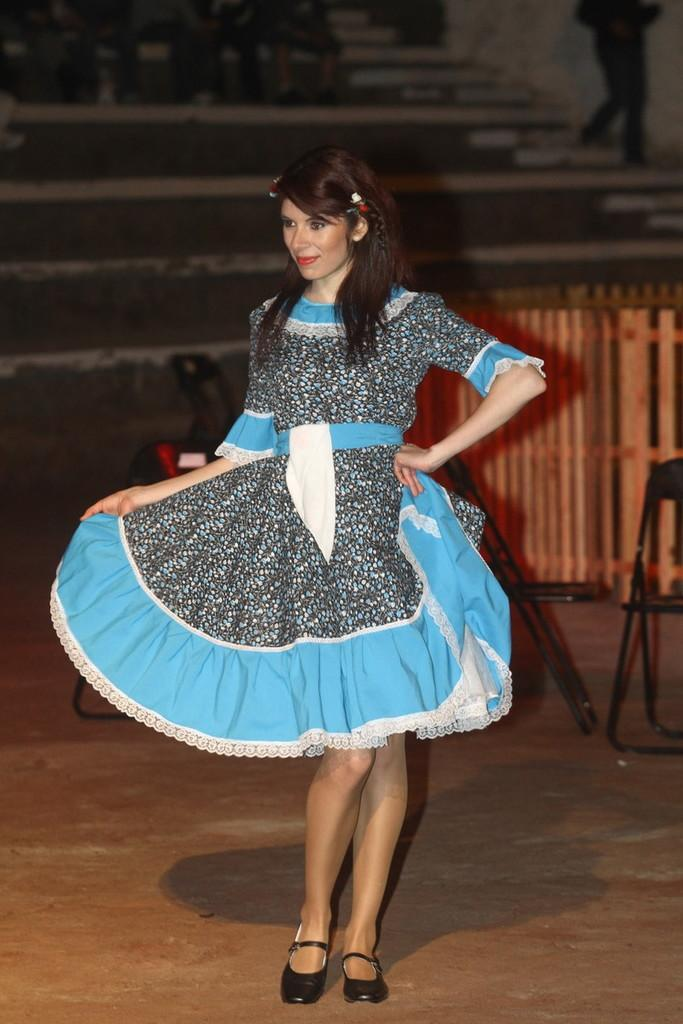Who is the main subject in the image? There is a girl in the image. What is the girl doing in the image? The girl is looking to the left side of the image. What objects are behind the girl? There are two chairs behind the girl. What type of barrier can be seen in the image? There is a wooden fence in the image. What type of steam is coming out of the girl's ears in the image? There is no steam coming out of the girl's ears in the image; she is simply looking to the left side. 